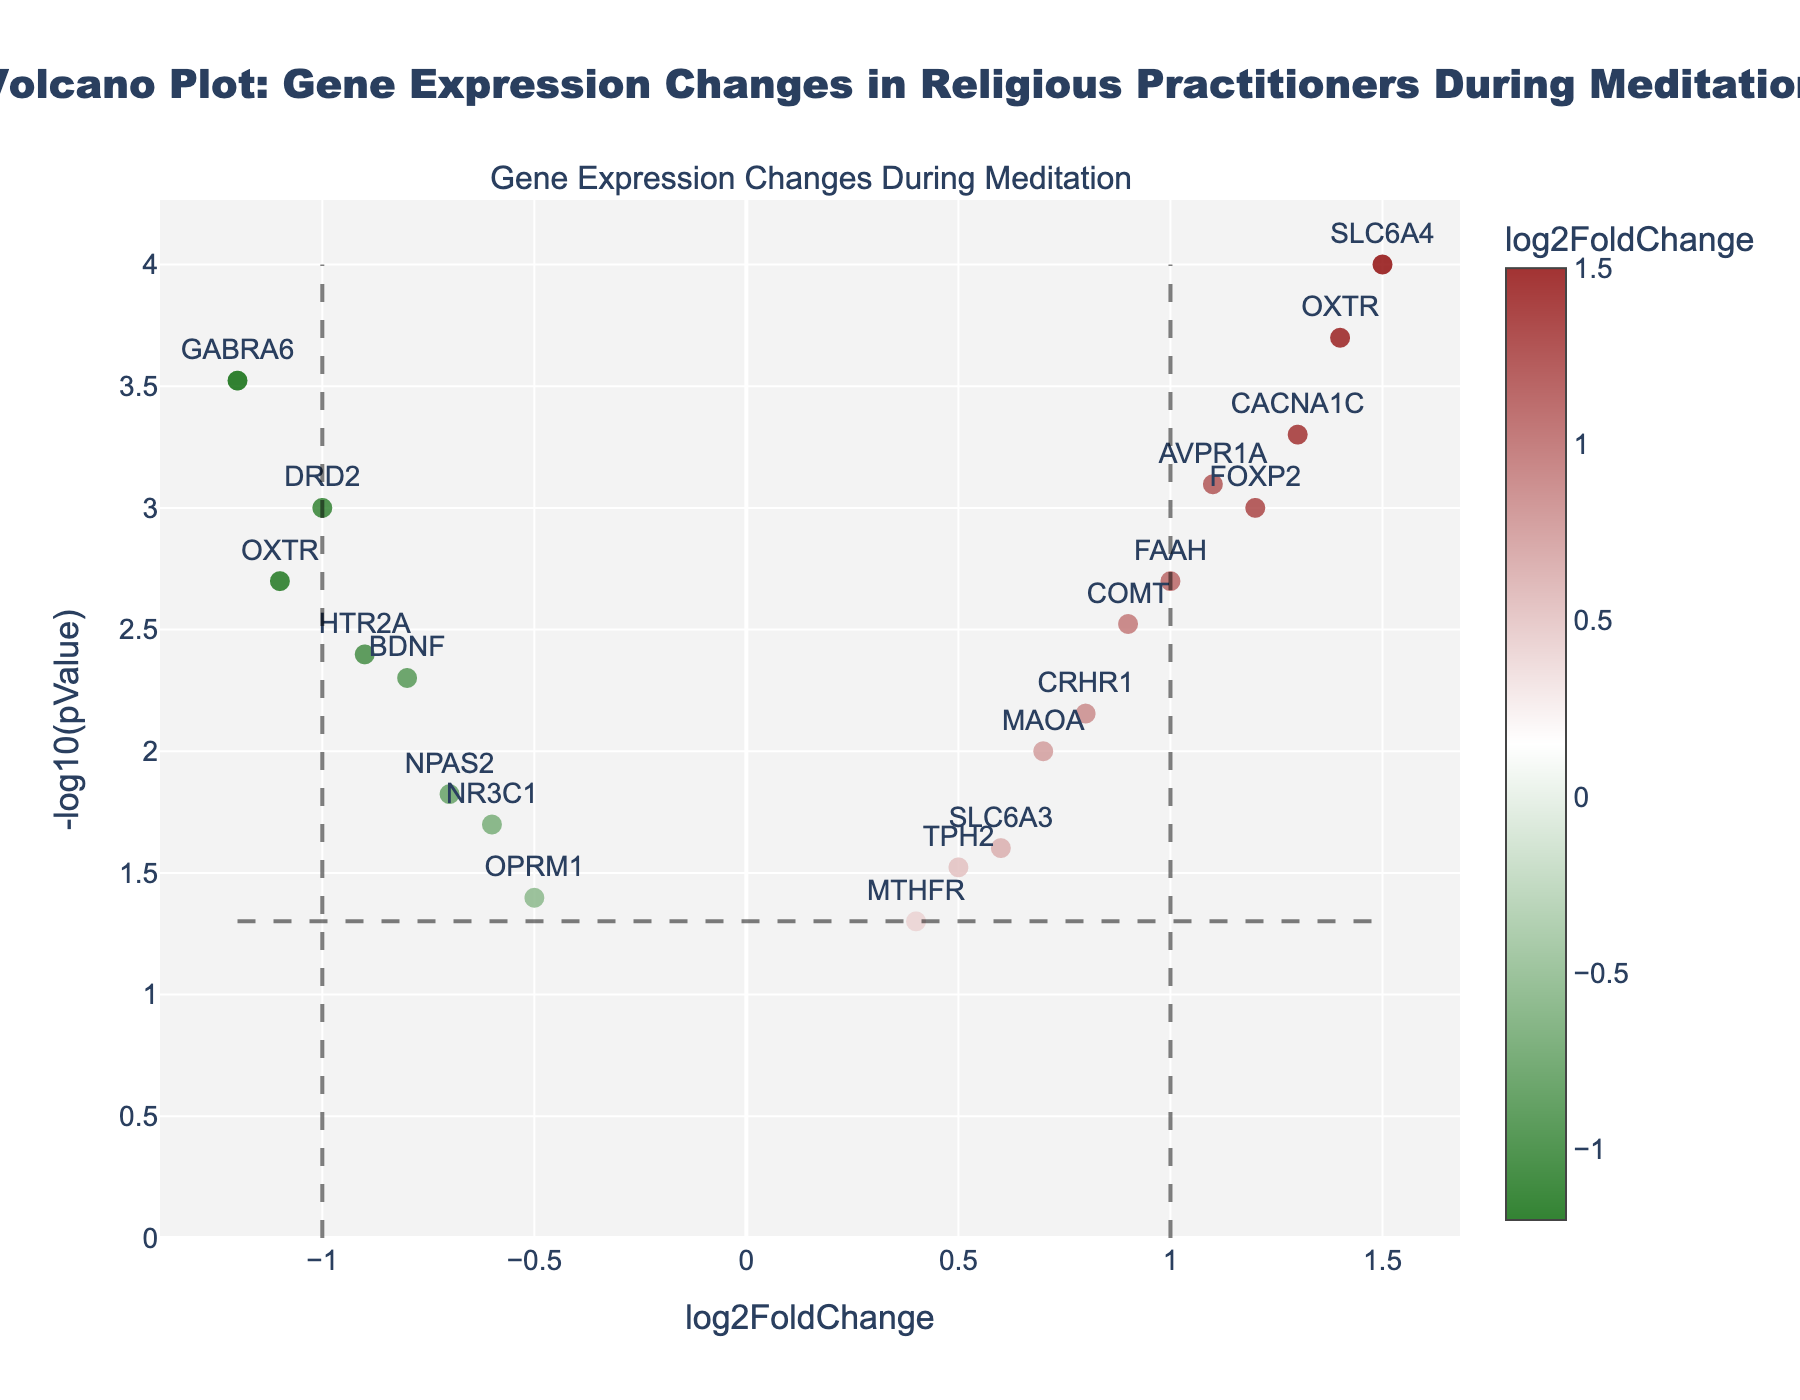What is the title of the plot? The title is located at the top center of the plot, in bold lettering. It reads: "Volcano Plot: Gene Expression Changes in Religious Practitioners During Meditation".
Answer: Volcano Plot: Gene Expression Changes in Religious Practitioners During Meditation How many genes are represented in the plot? Each marker on the plot represents a gene, and they are labeled with their respective names. Counting all the markers gives the total number of genes. By counting all the labeled markers, we see that there are 19 genes represented.
Answer: 19 Which gene has the highest log2FoldChange value? The highest log2FoldChange value corresponds to the gene with the most positive x-axis value. The furthest marker to the right is for the gene SLC6A4, with a log2FoldChange value of 1.5.
Answer: SLC6A4 Which gene has the lowest p-value? The gene with the lowest p-value will have the highest -log10(pValue) on the y-axis. From the plot, the highest point on the y-axis is for the gene SLC6A4.
Answer: SLC6A4 Are there any genes with a log2FoldChange value greater than 1 and a p-value less than 0.001? If so, name them. To answer this, we need to identify markers above the horizontal dashed line (-log10(pValue) > -log10(0.001)) and to the right of the vertical line at log2FoldChange = 1. According to the plot, the genes SLC6A4 and CACNA1C meet these criteria.
Answer: SLC6A4, CACNA1C Which gene shows the most significant decrease in expression (negative log2FoldChange) with a p-value less than 0.005? For this, we look at genes with the lowest log2FoldChange values (furthest to the left) and p-values below 0.005 (above the horizontal dashed line). The gene OXTR, with a log2FoldChange of -1.1 and a p-value of 0.002, is the most significant.
Answer: OXTR How many genes have a p-value below the threshold of 0.05? The horizontal dashed line on the plot indicates the p-value threshold of 0.05. Genes above this line have p-values below 0.05. Counting all markers above this line reveals 17 genes.
Answer: 17 Which genes have log2FoldChange values that fall between -0.5 and 0.5? We need to look for genes within the x-axis range of -0.5 to 0.5. The plot shows three such genes: TPH2 (0.5), NR3C1 (-0.6), and OPRM1 (0.4).
Answer: TPH2, NR3C1, OPRM1 